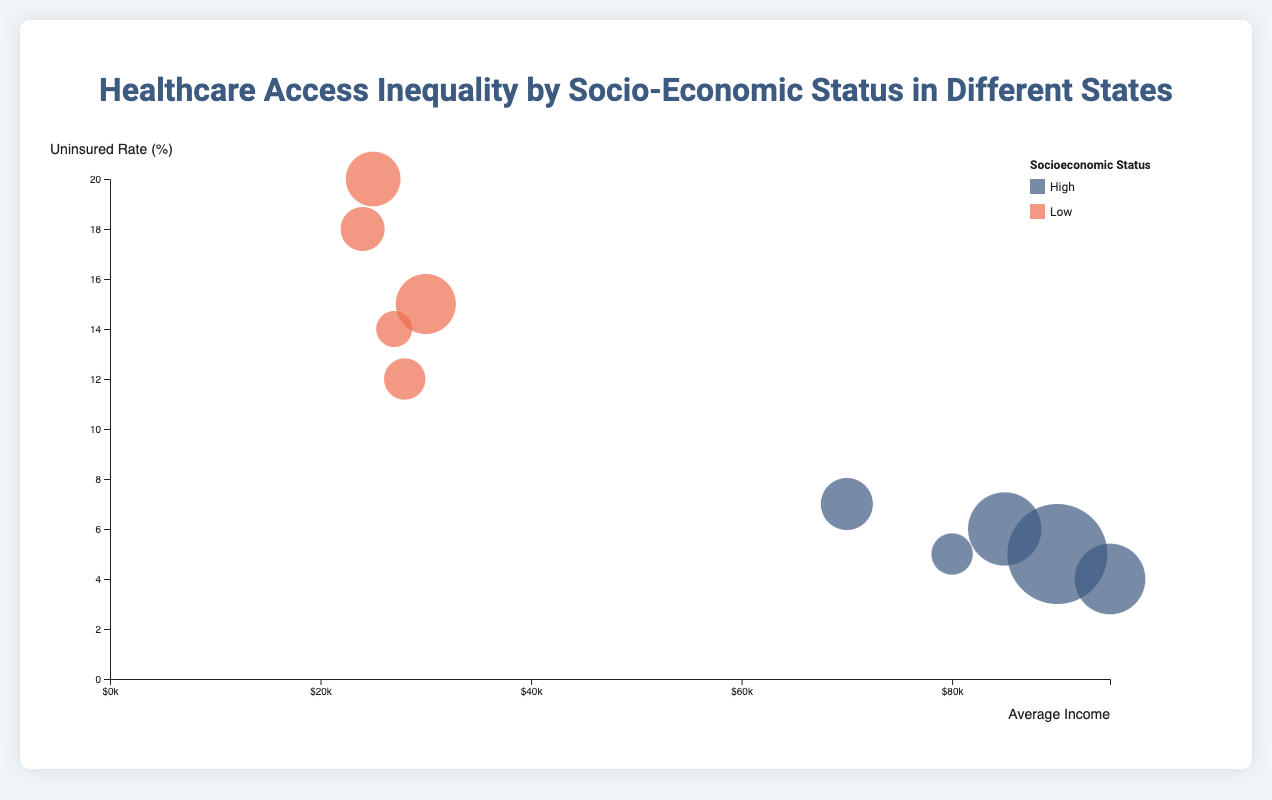What is the title of the figure? The title of the figure is usually located at the top and is intended to give an overview of what the visualization represents. In this case, the title is clearly stated.
Answer: Healthcare Access Inequality by Socio-Economic Status in Different States Which color represents high socioeconomic status? Legend information, typically found within the chart or in a separate key, describes the colors used in the chart. The legend at the top-right of the figure identifies that the color #3d5a80 represents "High" socioeconomic status.
Answer: Blue What does the size of the bubbles represent? The size of the bubbles often encodes the magnitude of a particular variable. According to the script, the size of each bubble represents the population of the socioeconomic group in each state.
Answer: Population What does the x-axis represent? The x-axis label is generally placed either below the horizontal axis or along it. In this figure, the x-axis is labeled "Average Income," indicating it depicts the average income of each socioeconomic group in dollars.
Answer: Average Income Which state has the highest number of hospitals for the high socioeconomic status? You need to hover over the bubbles and read the tooltips that show the number of hospitals per state and socioeconomic status. California's high SES group has the highest number of hospitals, with a total of 250.
Answer: California How does the uninsured rate compare between high and low socioeconomic groups in Texas? By looking at the y-axis (Uninsured Rate) and identifying the corresponding bubbles for Texas, it can be seen that the high SES group has a 6% rate, while the low SES group has a 20% rate.
Answer: High SES: 6%, Low SES: 20% Which state has the lowest average income among the high socioeconomic status groups? Look at the position of the high SES bubbles on the x-axis. The Florida bubble is the furthest to the left among high SES groups, indicating the lowest average income.
Answer: Florida What is the range of average incomes for the depicted states? Find the minimum and maximum values on the x-axis where the bubbles are plotted. The minimum is just below $70,000 (Florida, High SES), and the maximum is $95,000 (New York, High SES).
Answer: $70,000 to $95,000 Which state has the smallest bubble, and what does it represent? The bubble size represents population. By comparing bubble sizes, the smallest one is for New York (Low SES), indicating the smallest population among the groups.
Answer: New York (Low SES) What is the average uninsured rate between the high and low socioeconomic groups in Illinois? To find the answer, calculate the average of 5% (High SES) and 14% (Low SES) by summing them and dividing by two. (5 + 14) / 2 = 9.5%
Answer: 9.5% 